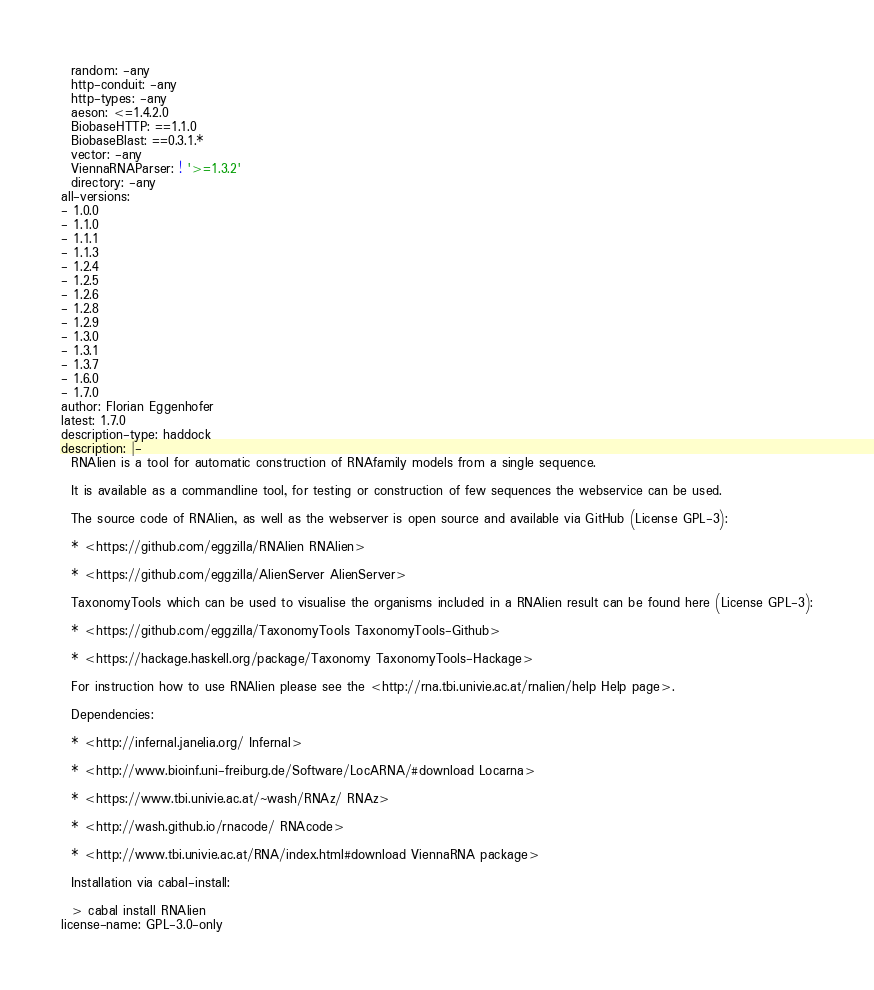<code> <loc_0><loc_0><loc_500><loc_500><_YAML_>  random: -any
  http-conduit: -any
  http-types: -any
  aeson: <=1.4.2.0
  BiobaseHTTP: ==1.1.0
  BiobaseBlast: ==0.3.1.*
  vector: -any
  ViennaRNAParser: ! '>=1.3.2'
  directory: -any
all-versions:
- 1.0.0
- 1.1.0
- 1.1.1
- 1.1.3
- 1.2.4
- 1.2.5
- 1.2.6
- 1.2.8
- 1.2.9
- 1.3.0
- 1.3.1
- 1.3.7
- 1.6.0
- 1.7.0
author: Florian Eggenhofer
latest: 1.7.0
description-type: haddock
description: |-
  RNAlien is a tool for automatic construction of RNAfamily models from a single sequence.

  It is available as a commandline tool, for testing or construction of few sequences the webservice can be used.

  The source code of RNAlien, as well as the webserver is open source and available via GitHub (License GPL-3):

  * <https://github.com/eggzilla/RNAlien RNAlien>

  * <https://github.com/eggzilla/AlienServer AlienServer>

  TaxonomyTools which can be used to visualise the organisms included in a RNAlien result can be found here (License GPL-3):

  * <https://github.com/eggzilla/TaxonomyTools TaxonomyTools-Github>

  * <https://hackage.haskell.org/package/Taxonomy TaxonomyTools-Hackage>

  For instruction how to use RNAlien please see the <http://rna.tbi.univie.ac.at/rnalien/help Help page>.

  Dependencies:

  * <http://infernal.janelia.org/ Infernal>

  * <http://www.bioinf.uni-freiburg.de/Software/LocARNA/#download Locarna>

  * <https://www.tbi.univie.ac.at/~wash/RNAz/ RNAz>

  * <http://wash.github.io/rnacode/ RNAcode>

  * <http://www.tbi.univie.ac.at/RNA/index.html#download ViennaRNA package>

  Installation via cabal-install:

  > cabal install RNAlien
license-name: GPL-3.0-only
</code> 